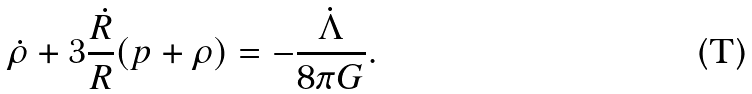<formula> <loc_0><loc_0><loc_500><loc_500>\dot { \rho } + 3 \frac { \dot { R } } { R } ( p + \rho ) = - \frac { \dot { \Lambda } } { 8 \pi G } .</formula> 